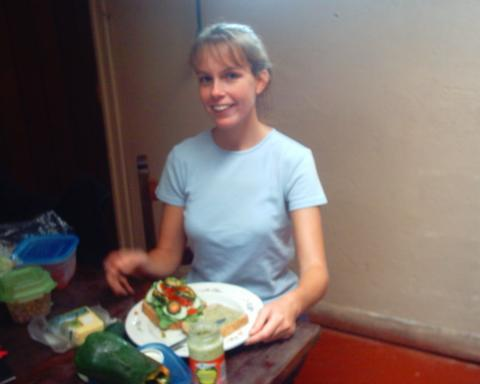What is this woman going to eat?

Choices:
A) steak
B) burrito
C) taco
D) sandwich sandwich 